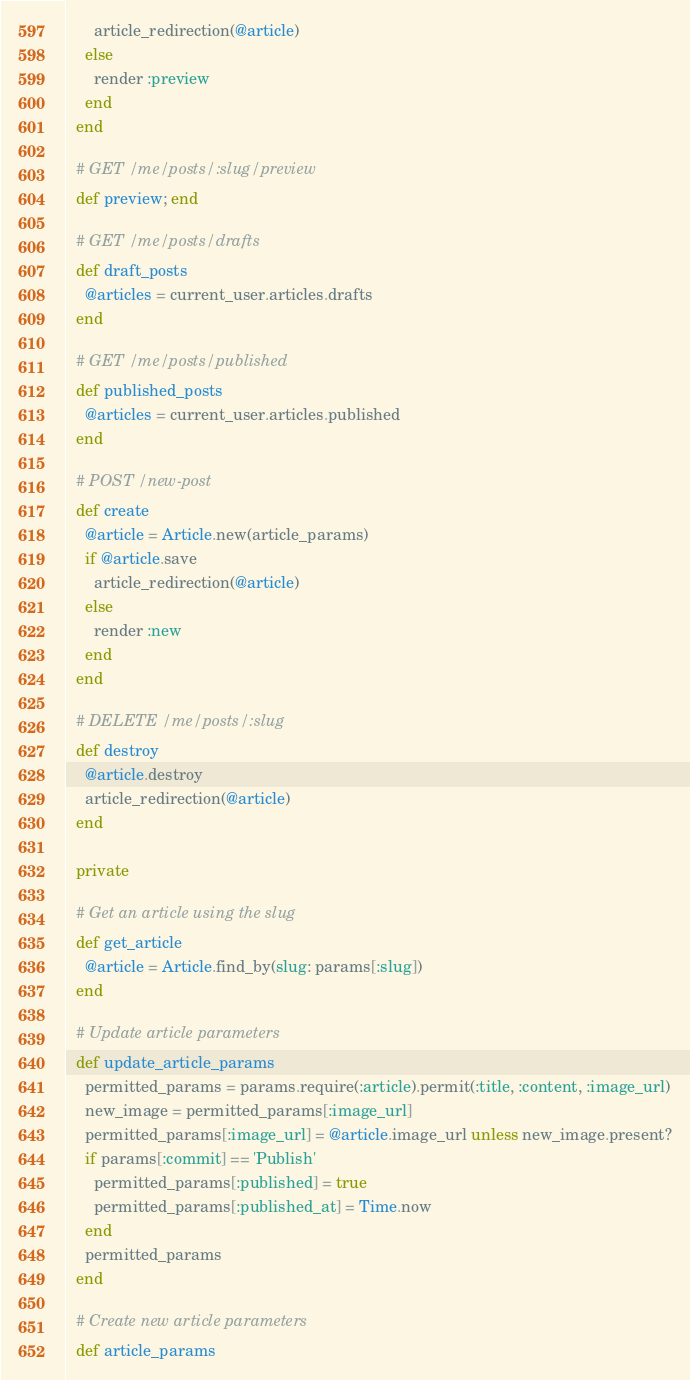<code> <loc_0><loc_0><loc_500><loc_500><_Ruby_>      article_redirection(@article)
    else
      render :preview
    end
  end

  # GET /me/posts/:slug/preview
  def preview; end

  # GET /me/posts/drafts
  def draft_posts
    @articles = current_user.articles.drafts
  end

  # GET /me/posts/published
  def published_posts
    @articles = current_user.articles.published
  end

  # POST /new-post
  def create
    @article = Article.new(article_params)
    if @article.save
      article_redirection(@article)
    else
      render :new
    end
  end

  # DELETE /me/posts/:slug
  def destroy
    @article.destroy
    article_redirection(@article)
  end

  private

  # Get an article using the slug
  def get_article
    @article = Article.find_by(slug: params[:slug])
  end

  # Update article parameters
  def update_article_params
    permitted_params = params.require(:article).permit(:title, :content, :image_url)
    new_image = permitted_params[:image_url]
    permitted_params[:image_url] = @article.image_url unless new_image.present?
    if params[:commit] == 'Publish'
      permitted_params[:published] = true
      permitted_params[:published_at] = Time.now
    end
    permitted_params
  end

  # Create new article parameters
  def article_params</code> 